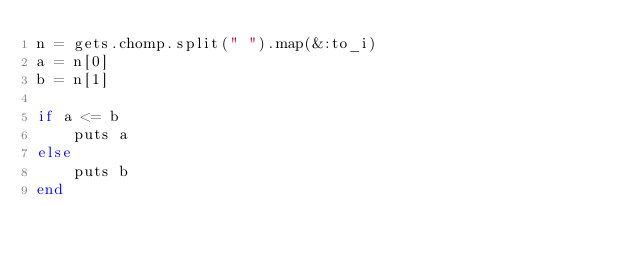Convert code to text. <code><loc_0><loc_0><loc_500><loc_500><_Ruby_>n = gets.chomp.split(" ").map(&:to_i)
a = n[0]
b = n[1]

if a <= b
    puts a
else
    puts b
end
</code> 